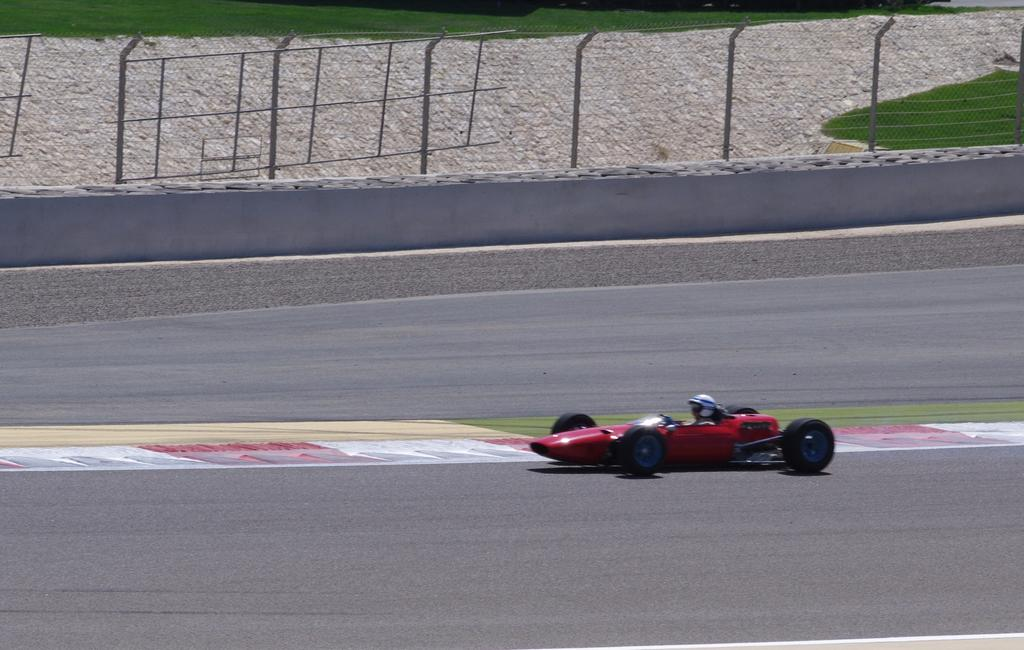What is the main subject of the image? There is a person in the image. What is the person doing in the image? The person is riding a red color car. What can be seen in the background of the image? There is grass in the background of the image. What is located in the middle of the image? There is fencing in the middle of the image. What safety gear is the person wearing? The person is wearing a helmet. What type of string is being used to measure the angle of the car in the image? There is no string or angle measurement present in the image; it simply shows a person riding a red color car with a helmet on. 